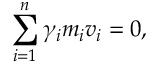<formula> <loc_0><loc_0><loc_500><loc_500>\sum _ { i = 1 } ^ { n } \gamma _ { i } m _ { i } v _ { i } = 0 ,</formula> 